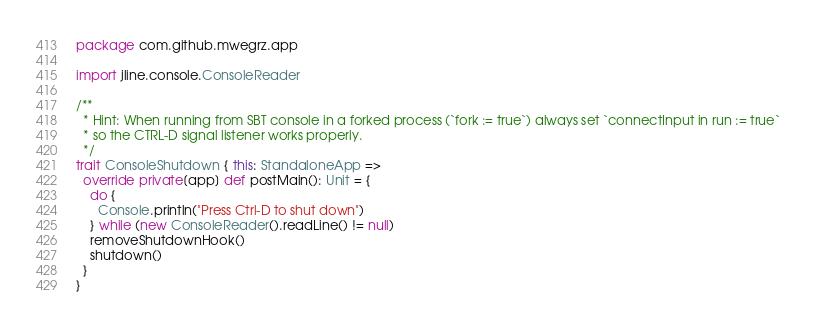Convert code to text. <code><loc_0><loc_0><loc_500><loc_500><_Scala_>package com.github.mwegrz.app

import jline.console.ConsoleReader

/**
  * Hint: When running from SBT console in a forked process (`fork := true`) always set `connectInput in run := true`
  * so the CTRL-D signal listener works properly.
  */
trait ConsoleShutdown { this: StandaloneApp =>
  override private[app] def postMain(): Unit = {
    do {
      Console.println("Press Ctrl-D to shut down")
    } while (new ConsoleReader().readLine() != null)
    removeShutdownHook()
    shutdown()
  }
}
</code> 